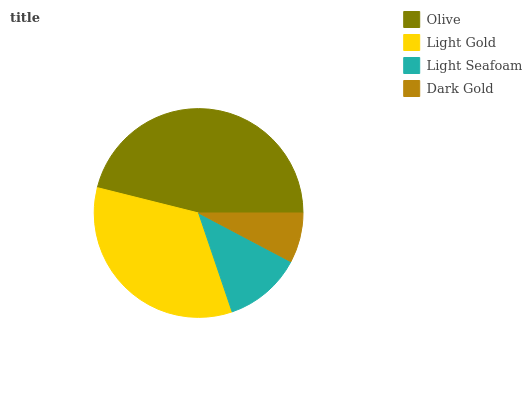Is Dark Gold the minimum?
Answer yes or no. Yes. Is Olive the maximum?
Answer yes or no. Yes. Is Light Gold the minimum?
Answer yes or no. No. Is Light Gold the maximum?
Answer yes or no. No. Is Olive greater than Light Gold?
Answer yes or no. Yes. Is Light Gold less than Olive?
Answer yes or no. Yes. Is Light Gold greater than Olive?
Answer yes or no. No. Is Olive less than Light Gold?
Answer yes or no. No. Is Light Gold the high median?
Answer yes or no. Yes. Is Light Seafoam the low median?
Answer yes or no. Yes. Is Dark Gold the high median?
Answer yes or no. No. Is Dark Gold the low median?
Answer yes or no. No. 